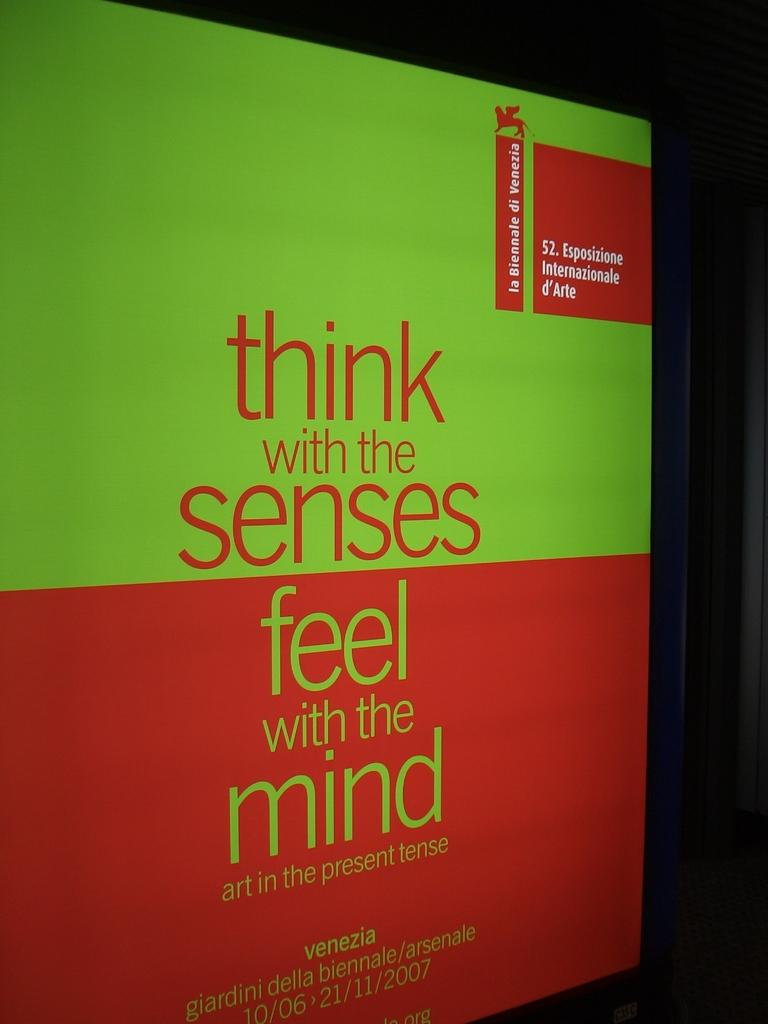What is present in the image that features a design or message? The image contains a poster. What colors are used on the poster? The poster has green and red colors. What can be found on the poster besides the colors? There is text written on the poster. How would you describe the overall appearance of the image? The background of the image is dark. What type of crime is being committed in the image? There is no indication of any crime being committed in the image; it features a poster with green and red colors and text. How does the monkey interact with the poster in the image? There is no monkey present in the image; it only contains a poster with text and colors. 